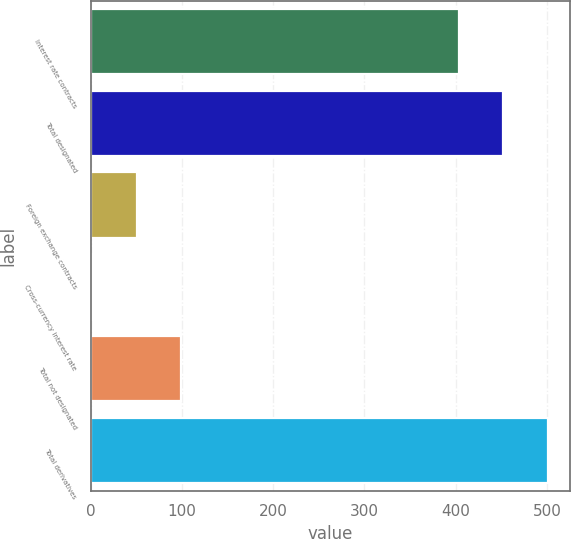Convert chart to OTSL. <chart><loc_0><loc_0><loc_500><loc_500><bar_chart><fcel>Interest rate contracts<fcel>Total designated<fcel>Foreign exchange contracts<fcel>Cross-currency interest rate<fcel>Total not designated<fcel>Total derivatives<nl><fcel>404<fcel>452.3<fcel>50.3<fcel>2<fcel>98.6<fcel>500.6<nl></chart> 